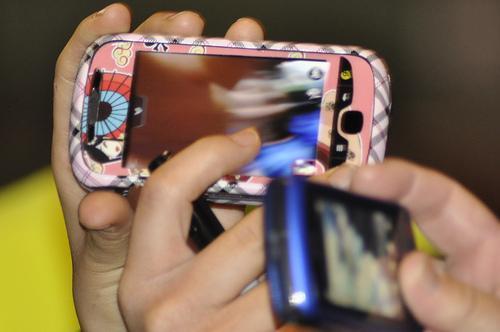How many phones are in the photo?
Give a very brief answer. 2. 